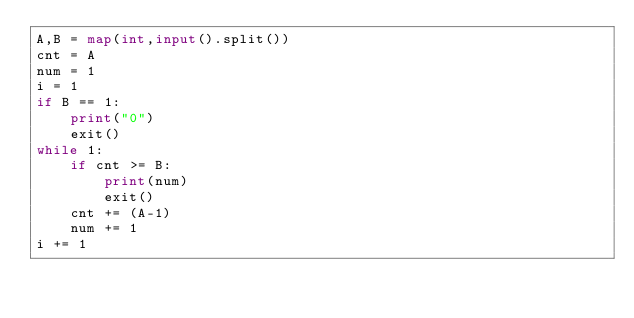<code> <loc_0><loc_0><loc_500><loc_500><_Python_>A,B = map(int,input().split())
cnt = A
num = 1
i = 1
if B == 1:
    print("0")
    exit()
while 1:
    if cnt >= B:
        print(num)
        exit() 
    cnt += (A-1)
    num += 1
i += 1
    
</code> 